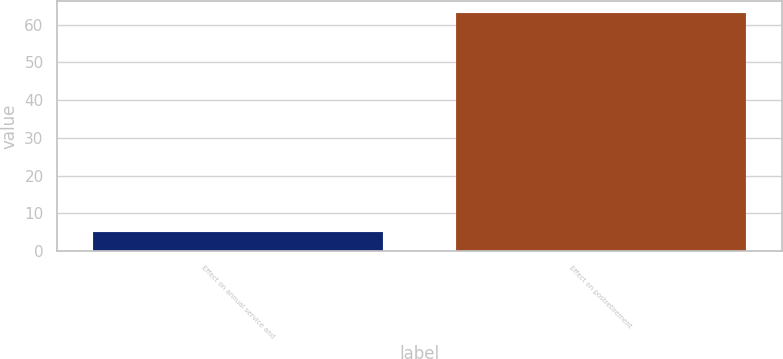Convert chart to OTSL. <chart><loc_0><loc_0><loc_500><loc_500><bar_chart><fcel>Effect on annual service and<fcel>Effect on postretirement<nl><fcel>5<fcel>63<nl></chart> 